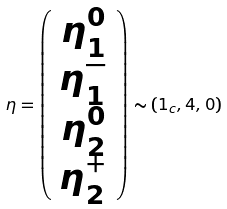<formula> <loc_0><loc_0><loc_500><loc_500>\eta = \left ( \begin{array} { c } \eta ^ { 0 } _ { 1 } \\ \eta ^ { - } _ { 1 } \\ \eta ^ { 0 } _ { 2 } \\ \eta ^ { + } _ { 2 } \end{array} \right ) \sim ( { 1 } _ { c } , { 4 } , 0 )</formula> 